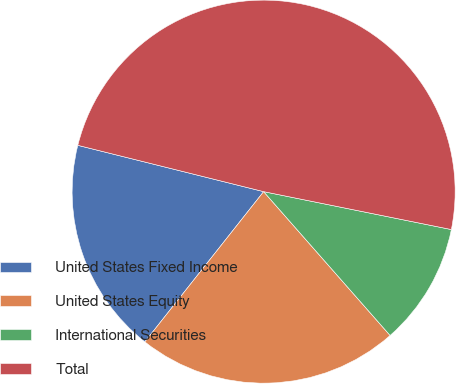<chart> <loc_0><loc_0><loc_500><loc_500><pie_chart><fcel>United States Fixed Income<fcel>United States Equity<fcel>International Securities<fcel>Total<nl><fcel>18.24%<fcel>22.13%<fcel>10.35%<fcel>49.29%<nl></chart> 